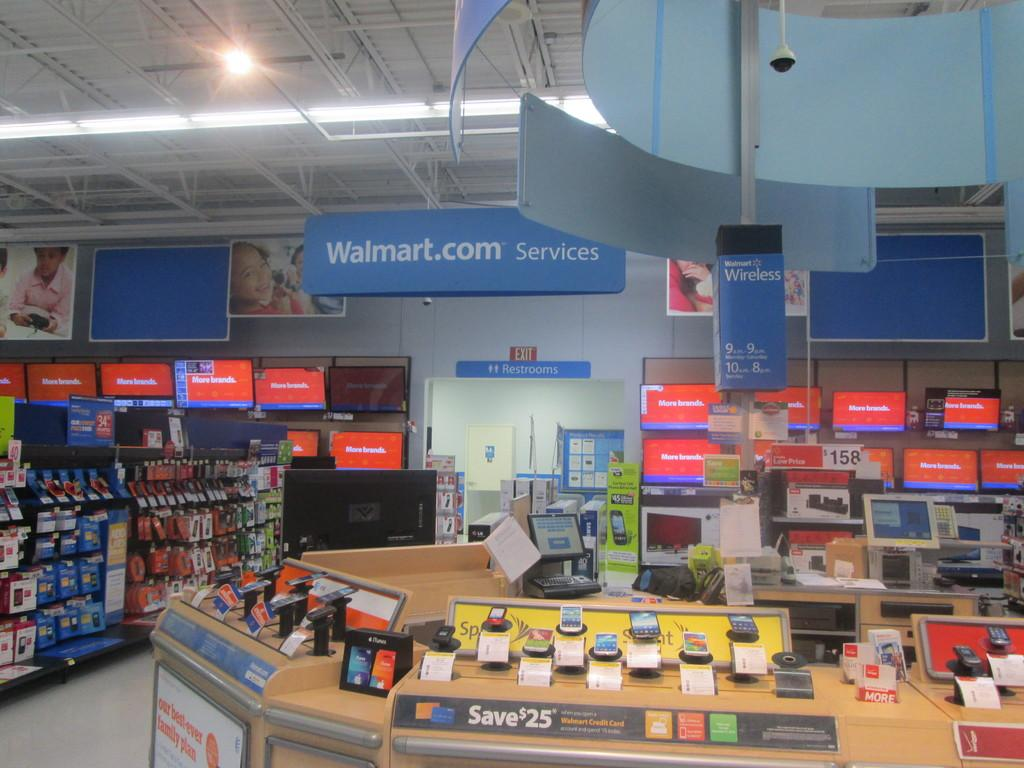Provide a one-sentence caption for the provided image. A display in walmart with a sign advertising save 25 dollars. 